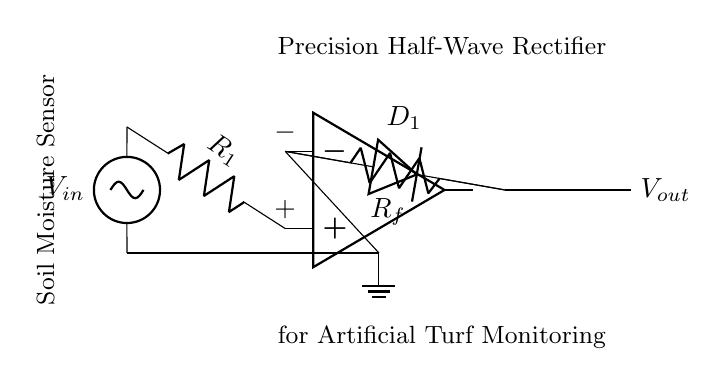What is the input voltage? The input voltage is labeled as V-in, which is provided by the source on the left side of the diagram.
Answer: V-in What component acts as the rectifying element in this circuit? The component that acts as the rectifying element is the diode labeled D-1, which allows current to pass in one direction and blocks it in the reverse direction.
Answer: D-1 What is the feedback component in this circuit? The feedback component is the resistor labeled R-f, which helps to control the operating characteristics of the operational amplifier by providing feedback to the inverting terminal.
Answer: R-f How many resistors are in this circuit? There are two resistors in this circuit, one labeled R-1 at the input and another labeled R-f in the feedback loop.
Answer: Two What is the function of the operational amplifier in the circuit? The operational amplifier is used to amplify the input signal and is configured to create a precision rectifier, which allows for accurate detection of the input voltage.
Answer: Amplification What type of rectifier is shown in the circuit? The circuit illustrates a precision half-wave rectifier, which only allows one half of the input signal to be passed to the output while enhancing low-level signals.
Answer: Precision half-wave rectifier What is the purpose of this circuit in relation to the artificial turf? The purpose of this circuit is to monitor soil moisture levels by rectifying the signal from the soil moisture sensor, enabling accurate measurement necessary for maintaining artificial turf.
Answer: Soil moisture measurement 